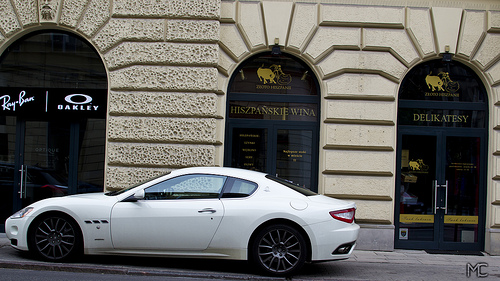<image>
Can you confirm if the car is behind the store? No. The car is not behind the store. From this viewpoint, the car appears to be positioned elsewhere in the scene. 